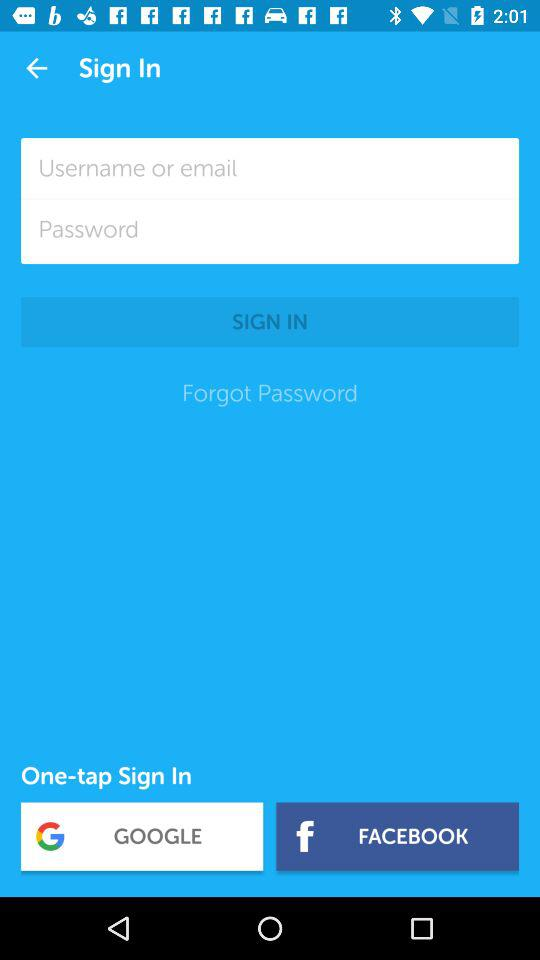What are the options to sign in? The options are "Username or email", "GOOGLE" and "FACEBOOK". 